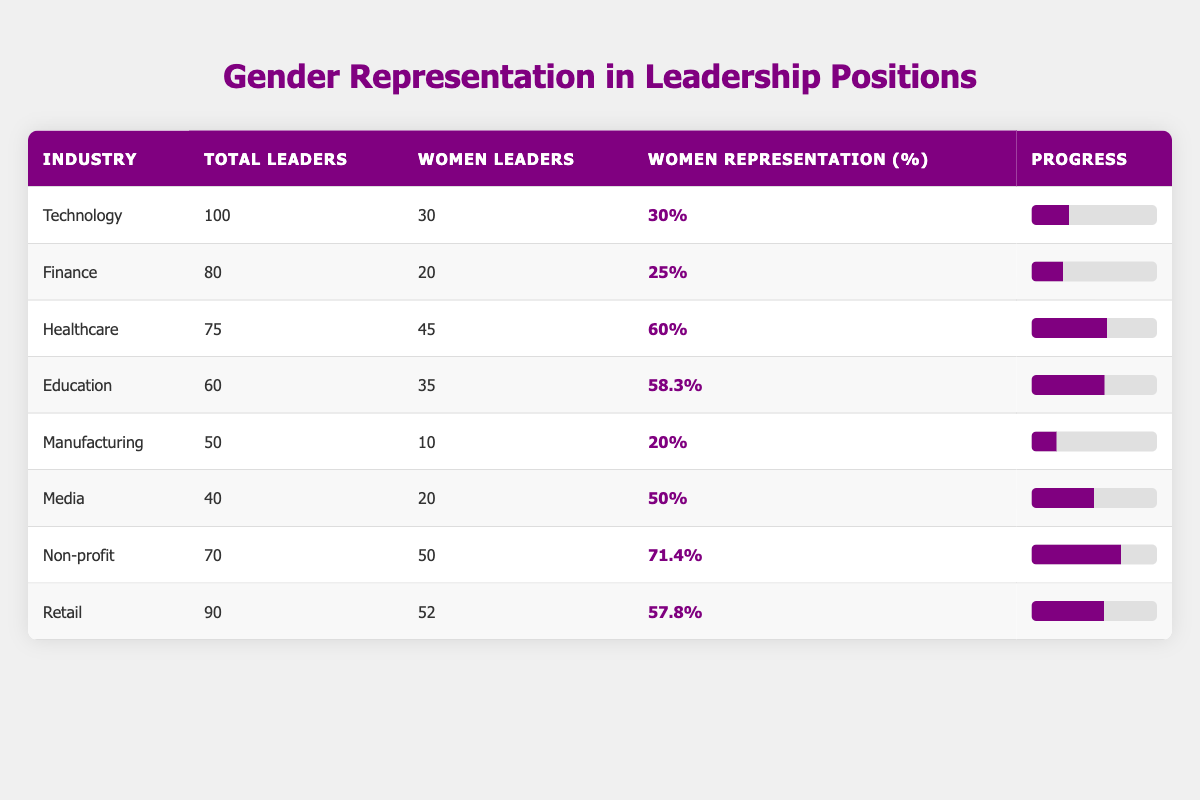What is the percentage of women leaders in the Healthcare industry? The table indicates that there are 45 women leaders out of a total of 75 leaders in the Healthcare industry. The percentage is calculated as (45/75) * 100 = 60%.
Answer: 60% Which industry has the highest percentage of women representation? By examining the percentages in the table, the Non-profit industry has the highest representation at 71.4%.
Answer: Non-profit How many more women leaders are there in the Retail industry compared to the Manufacturing industry? There are 52 women leaders in Retail and 10 in Manufacturing. The difference is calculated as 52 - 10 = 42.
Answer: 42 What is the average percentage of women leaders across all listed industries? To find the average, sum the percentages: (30 + 25 + 60 + 58.3 + 20 + 50 + 71.4 + 57.8) = 373.5 and divide by the number of industries (8): 373.5 / 8 = 46.6875, which is approximately 46.7%.
Answer: 46.7% Is the percentage of women leaders in Media greater than that in Finance? The table shows 50% women representation in Media and 25% in Finance. Therefore, 50% is greater than 25%.
Answer: Yes What is the total number of leaders across all industries listed in the table? The total can be found by summing the total leaders from each industry: 100 + 80 + 75 + 60 + 50 + 40 + 70 + 90 = 565.
Answer: 565 In how many industries is the representation of women leaders below 30%? The table indicates that only two industries have less than 30% representation: Technology (30%) and Finance (25%). Thus, the count is 2.
Answer: 2 Which industry has the least number of women leaders and what is that number? Upon reviewing the table, the industry with the least number of women leaders is Manufacturing, which has 10 women leaders.
Answer: 10 